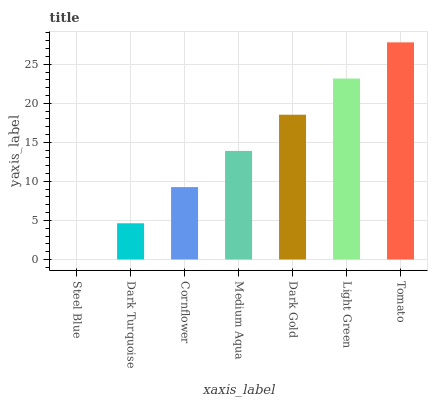Is Steel Blue the minimum?
Answer yes or no. Yes. Is Tomato the maximum?
Answer yes or no. Yes. Is Dark Turquoise the minimum?
Answer yes or no. No. Is Dark Turquoise the maximum?
Answer yes or no. No. Is Dark Turquoise greater than Steel Blue?
Answer yes or no. Yes. Is Steel Blue less than Dark Turquoise?
Answer yes or no. Yes. Is Steel Blue greater than Dark Turquoise?
Answer yes or no. No. Is Dark Turquoise less than Steel Blue?
Answer yes or no. No. Is Medium Aqua the high median?
Answer yes or no. Yes. Is Medium Aqua the low median?
Answer yes or no. Yes. Is Dark Gold the high median?
Answer yes or no. No. Is Steel Blue the low median?
Answer yes or no. No. 